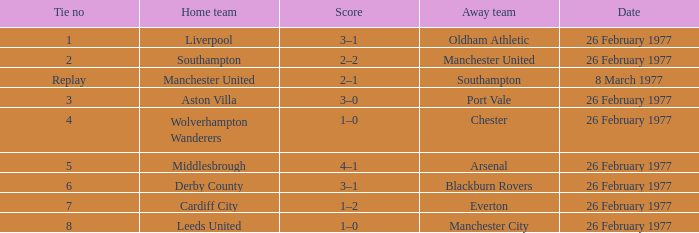Who was the home team that played against Manchester United? Southampton. Would you be able to parse every entry in this table? {'header': ['Tie no', 'Home team', 'Score', 'Away team', 'Date'], 'rows': [['1', 'Liverpool', '3–1', 'Oldham Athletic', '26 February 1977'], ['2', 'Southampton', '2–2', 'Manchester United', '26 February 1977'], ['Replay', 'Manchester United', '2–1', 'Southampton', '8 March 1977'], ['3', 'Aston Villa', '3–0', 'Port Vale', '26 February 1977'], ['4', 'Wolverhampton Wanderers', '1–0', 'Chester', '26 February 1977'], ['5', 'Middlesbrough', '4–1', 'Arsenal', '26 February 1977'], ['6', 'Derby County', '3–1', 'Blackburn Rovers', '26 February 1977'], ['7', 'Cardiff City', '1–2', 'Everton', '26 February 1977'], ['8', 'Leeds United', '1–0', 'Manchester City', '26 February 1977']]} 